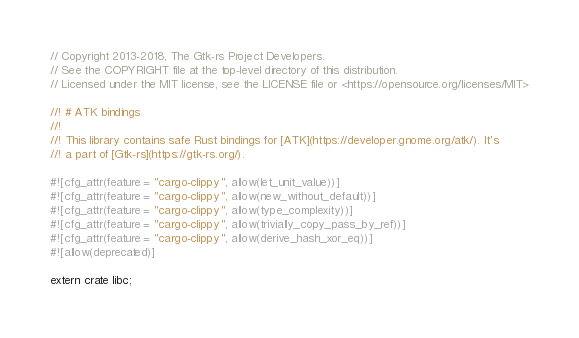Convert code to text. <code><loc_0><loc_0><loc_500><loc_500><_Rust_>// Copyright 2013-2018, The Gtk-rs Project Developers.
// See the COPYRIGHT file at the top-level directory of this distribution.
// Licensed under the MIT license, see the LICENSE file or <https://opensource.org/licenses/MIT>

//! # ATK bindings
//!
//! This library contains safe Rust bindings for [ATK](https://developer.gnome.org/atk/). It's
//! a part of [Gtk-rs](https://gtk-rs.org/).

#![cfg_attr(feature = "cargo-clippy", allow(let_unit_value))]
#![cfg_attr(feature = "cargo-clippy", allow(new_without_default))]
#![cfg_attr(feature = "cargo-clippy", allow(type_complexity))]
#![cfg_attr(feature = "cargo-clippy", allow(trivially_copy_pass_by_ref))]
#![cfg_attr(feature = "cargo-clippy", allow(derive_hash_xor_eq))]
#![allow(deprecated)]

extern crate libc;</code> 